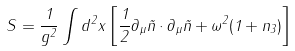<formula> <loc_0><loc_0><loc_500><loc_500>S = \frac { 1 } { g ^ { 2 } } \int d ^ { 2 } x \left [ \frac { 1 } { 2 } \partial _ { \mu } \vec { n } \cdot \partial _ { \mu } \vec { n } + \omega ^ { 2 } ( 1 + n _ { 3 } ) \right ]</formula> 